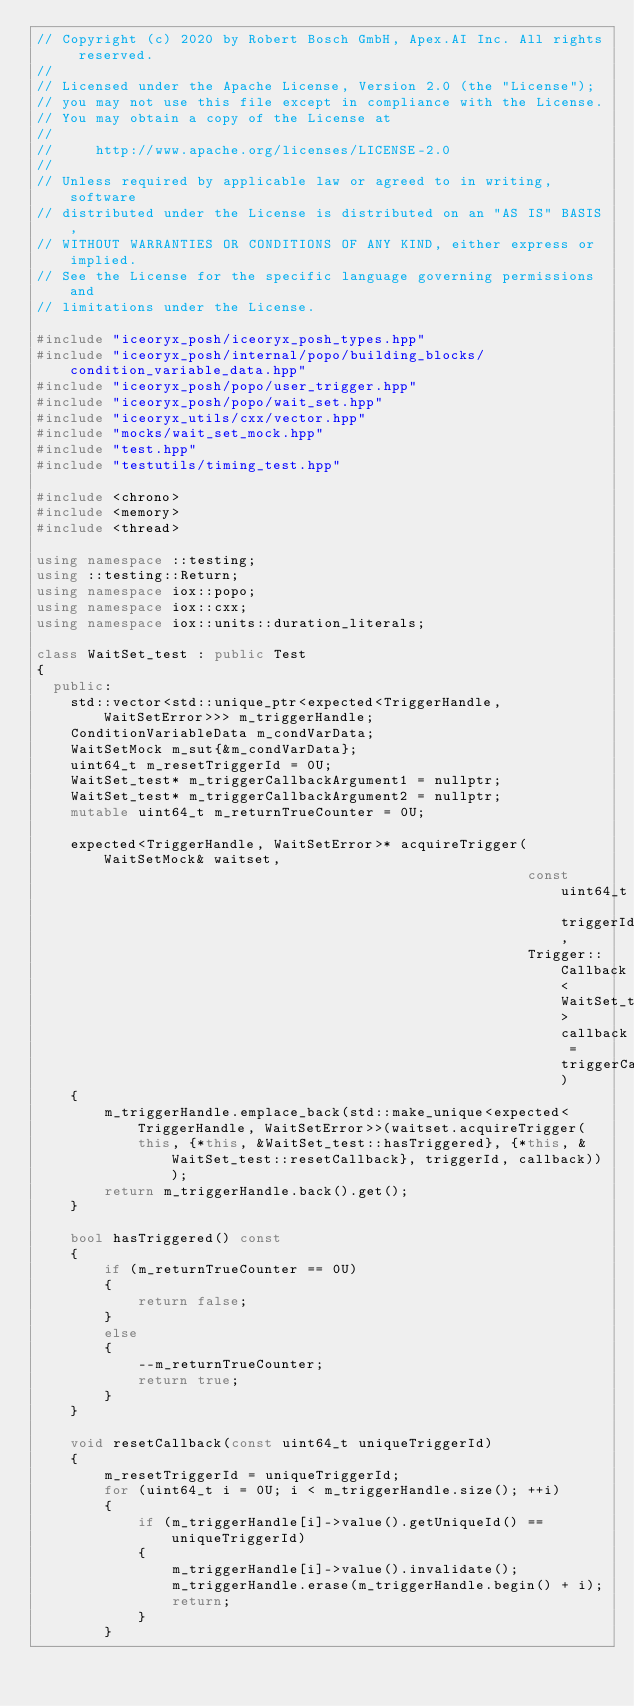Convert code to text. <code><loc_0><loc_0><loc_500><loc_500><_C++_>// Copyright (c) 2020 by Robert Bosch GmbH, Apex.AI Inc. All rights reserved.
//
// Licensed under the Apache License, Version 2.0 (the "License");
// you may not use this file except in compliance with the License.
// You may obtain a copy of the License at
//
//     http://www.apache.org/licenses/LICENSE-2.0
//
// Unless required by applicable law or agreed to in writing, software
// distributed under the License is distributed on an "AS IS" BASIS,
// WITHOUT WARRANTIES OR CONDITIONS OF ANY KIND, either express or implied.
// See the License for the specific language governing permissions and
// limitations under the License.

#include "iceoryx_posh/iceoryx_posh_types.hpp"
#include "iceoryx_posh/internal/popo/building_blocks/condition_variable_data.hpp"
#include "iceoryx_posh/popo/user_trigger.hpp"
#include "iceoryx_posh/popo/wait_set.hpp"
#include "iceoryx_utils/cxx/vector.hpp"
#include "mocks/wait_set_mock.hpp"
#include "test.hpp"
#include "testutils/timing_test.hpp"

#include <chrono>
#include <memory>
#include <thread>

using namespace ::testing;
using ::testing::Return;
using namespace iox::popo;
using namespace iox::cxx;
using namespace iox::units::duration_literals;

class WaitSet_test : public Test
{
  public:
    std::vector<std::unique_ptr<expected<TriggerHandle, WaitSetError>>> m_triggerHandle;
    ConditionVariableData m_condVarData;
    WaitSetMock m_sut{&m_condVarData};
    uint64_t m_resetTriggerId = 0U;
    WaitSet_test* m_triggerCallbackArgument1 = nullptr;
    WaitSet_test* m_triggerCallbackArgument2 = nullptr;
    mutable uint64_t m_returnTrueCounter = 0U;

    expected<TriggerHandle, WaitSetError>* acquireTrigger(WaitSetMock& waitset,
                                                          const uint64_t triggerId,
                                                          Trigger::Callback<WaitSet_test> callback = triggerCallback1)
    {
        m_triggerHandle.emplace_back(std::make_unique<expected<TriggerHandle, WaitSetError>>(waitset.acquireTrigger(
            this, {*this, &WaitSet_test::hasTriggered}, {*this, &WaitSet_test::resetCallback}, triggerId, callback)));
        return m_triggerHandle.back().get();
    }

    bool hasTriggered() const
    {
        if (m_returnTrueCounter == 0U)
        {
            return false;
        }
        else
        {
            --m_returnTrueCounter;
            return true;
        }
    }

    void resetCallback(const uint64_t uniqueTriggerId)
    {
        m_resetTriggerId = uniqueTriggerId;
        for (uint64_t i = 0U; i < m_triggerHandle.size(); ++i)
        {
            if (m_triggerHandle[i]->value().getUniqueId() == uniqueTriggerId)
            {
                m_triggerHandle[i]->value().invalidate();
                m_triggerHandle.erase(m_triggerHandle.begin() + i);
                return;
            }
        }</code> 